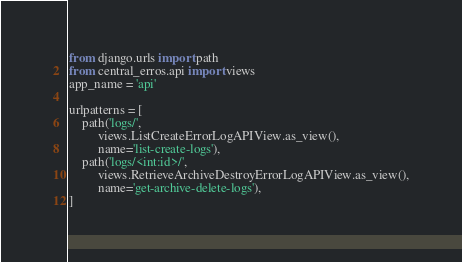<code> <loc_0><loc_0><loc_500><loc_500><_Python_>from django.urls import path
from central_erros.api import views
app_name = 'api'

urlpatterns = [
    path('logs/', 
         views.ListCreateErrorLogAPIView.as_view(), 
         name='list-create-logs'),
    path('logs/<int:id>/',
         views.RetrieveArchiveDestroyErrorLogAPIView.as_view(),
         name='get-archive-delete-logs'),
] 
</code> 